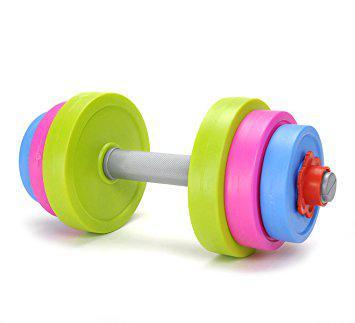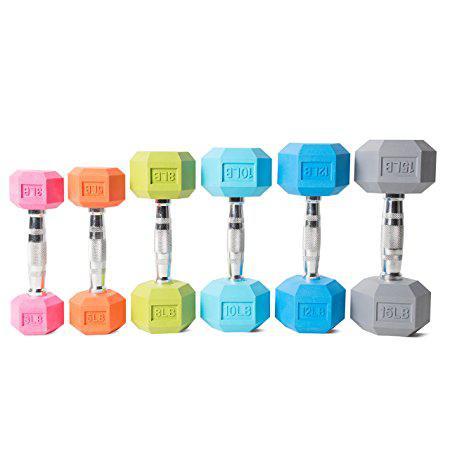The first image is the image on the left, the second image is the image on the right. Assess this claim about the two images: "There are no more than three weights in the image on the right.". Correct or not? Answer yes or no. No. The first image is the image on the left, the second image is the image on the right. Examine the images to the left and right. Is the description "An image shows a neat row of dumbbells arranged by weight that includes at least four different colored ends." accurate? Answer yes or no. Yes. 